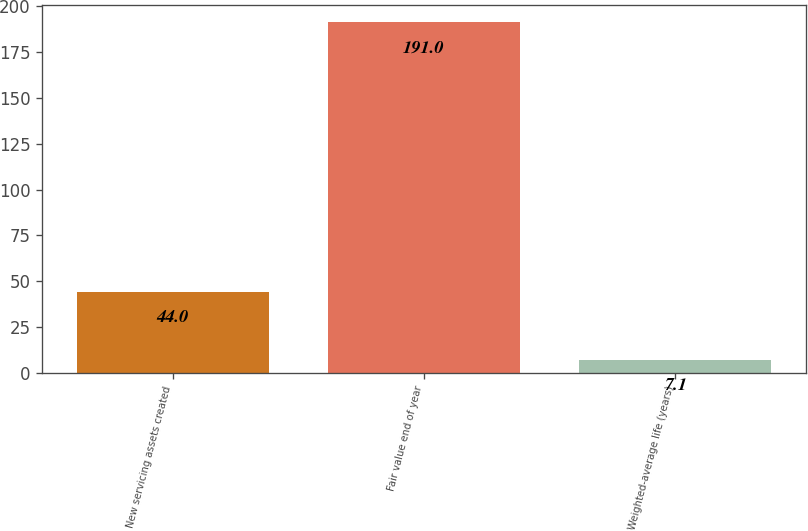<chart> <loc_0><loc_0><loc_500><loc_500><bar_chart><fcel>New servicing assets created<fcel>Fair value end of year<fcel>Weighted-average life (years)<nl><fcel>44<fcel>191<fcel>7.1<nl></chart> 